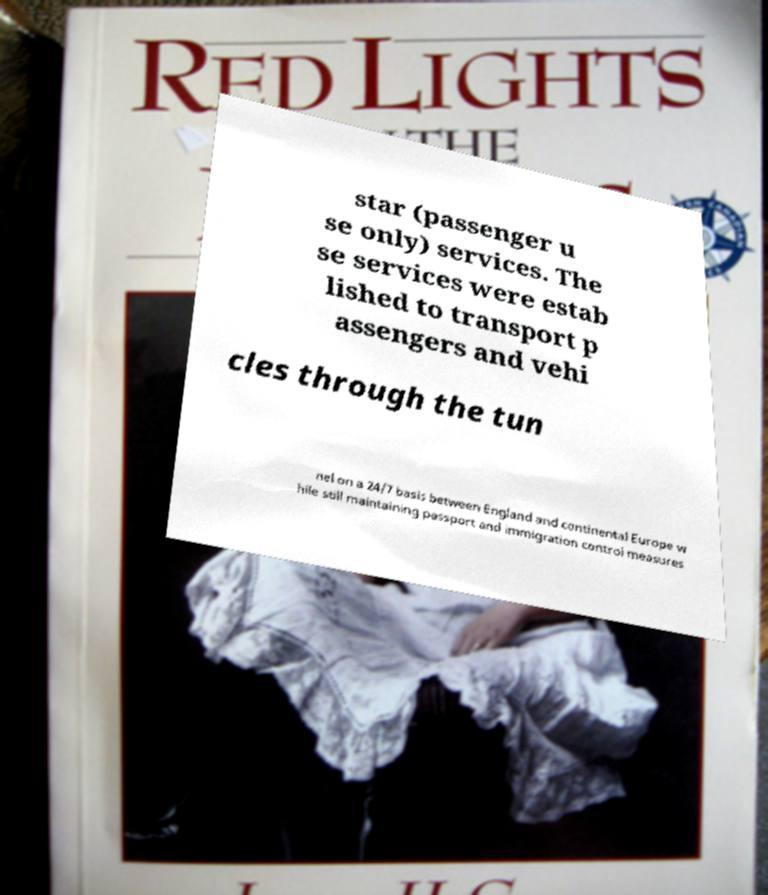Please read and relay the text visible in this image. What does it say? star (passenger u se only) services. The se services were estab lished to transport p assengers and vehi cles through the tun nel on a 24/7 basis between England and continental Europe w hile still maintaining passport and immigration control measures 